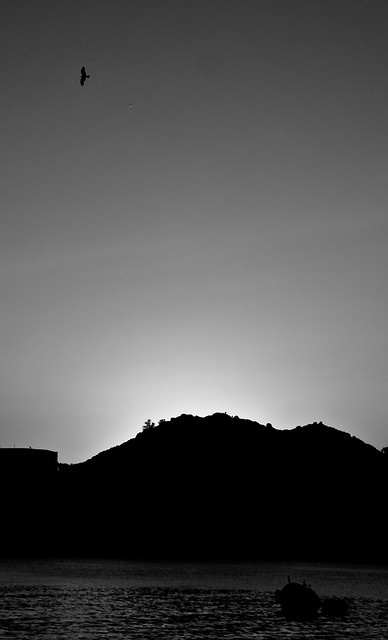Describe the objects in this image and their specific colors. I can see boat in black tones and bird in black and gray tones in this image. 